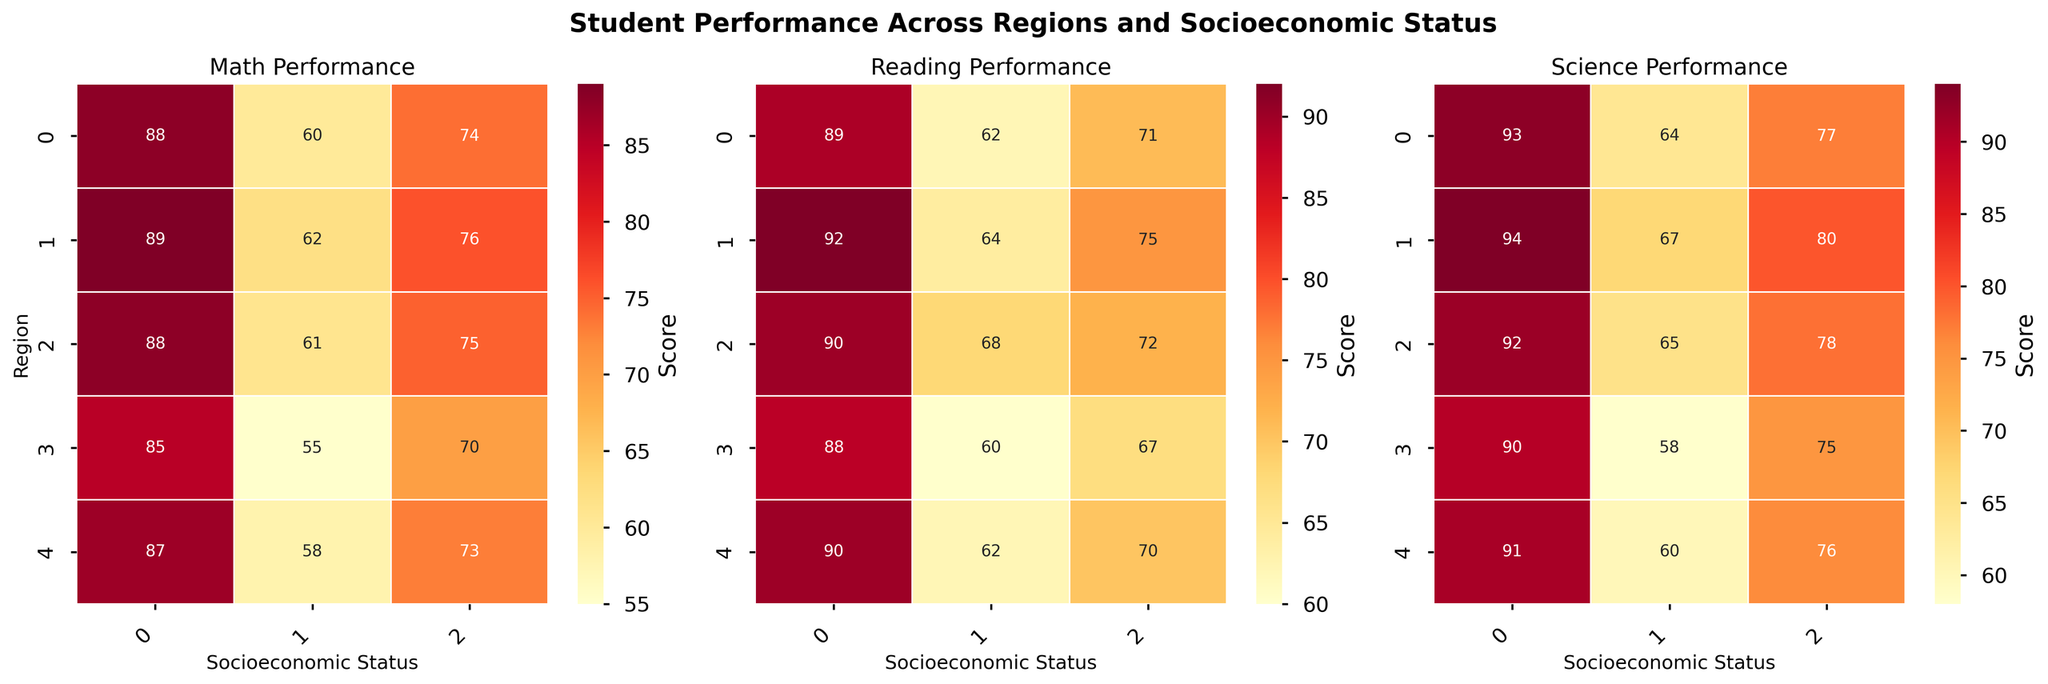What's the title of the figure? The title is displayed at the top of the figure in bold font. It succinctly describes what the figure is about.
Answer: Student Performance Across Regions and Socioeconomic Status What regions are represented in the heatmaps? The regions are listed along the y-axis of the heatmaps, denoted with row labels.
Answer: North, South, East, West, Central Which socioeconomic status group has the highest reading score in the North region? By looking at the heatmap for reading scores, find the North region row and identify the column with the highest value.
Answer: High In which region do students with low socioeconomic status have the lowest math score? Look at the math score heatmap, find the column for the low socioeconomic status group, and identify the region with the lowest value.
Answer: South What is the average science score for students with medium socioeconomic status in all regions? Add the medium socioeconomic status scores in the science score heatmap and divide by the number of regions: (78+75+80+76+77)/5.
Answer: 77.2 Compare the math scores for students with high socioeconomic status between the East and West regions. Which region has a higher score? Locate the "High" column in the math score heatmap, and compare the values for East and West regions.
Answer: East Do students in the South region generally perform better in science or reading? Compare the values for science and reading scores in the South region row across all socioeconomic status groups.
Answer: Science Which subject shows the highest overall performance for students with high socioeconomic status in all regions? Look at the high socioeconomic status column across all three heatmaps and identify the subject with the highest values.
Answer: Science How does the performance in math for students with low socioeconomic status in the Central region compare with those in the North region? Compare the values in the math score heatmap for "Low" socioeconomic status between the Central and North regions.
Answer: Central = 60, North = 61. North is slightly higher Is there a noticeable trend in the scores as socioeconomic status increases within each region? Examine each heatmap and note whether scores consistently increase from low to high socioeconomic status within the regions.
Answer: Yes 